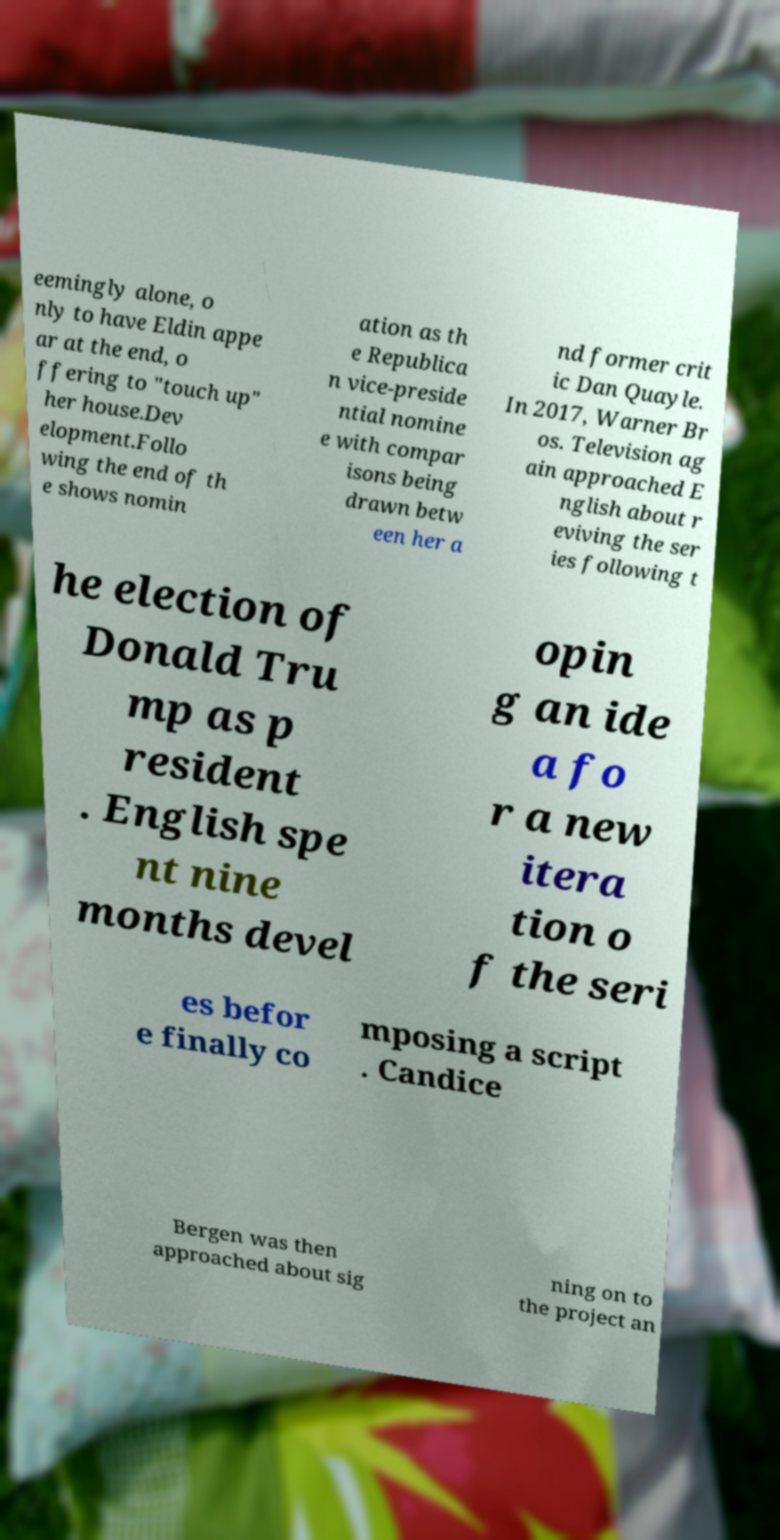Could you assist in decoding the text presented in this image and type it out clearly? eemingly alone, o nly to have Eldin appe ar at the end, o ffering to "touch up" her house.Dev elopment.Follo wing the end of th e shows nomin ation as th e Republica n vice-preside ntial nomine e with compar isons being drawn betw een her a nd former crit ic Dan Quayle. In 2017, Warner Br os. Television ag ain approached E nglish about r eviving the ser ies following t he election of Donald Tru mp as p resident . English spe nt nine months devel opin g an ide a fo r a new itera tion o f the seri es befor e finally co mposing a script . Candice Bergen was then approached about sig ning on to the project an 